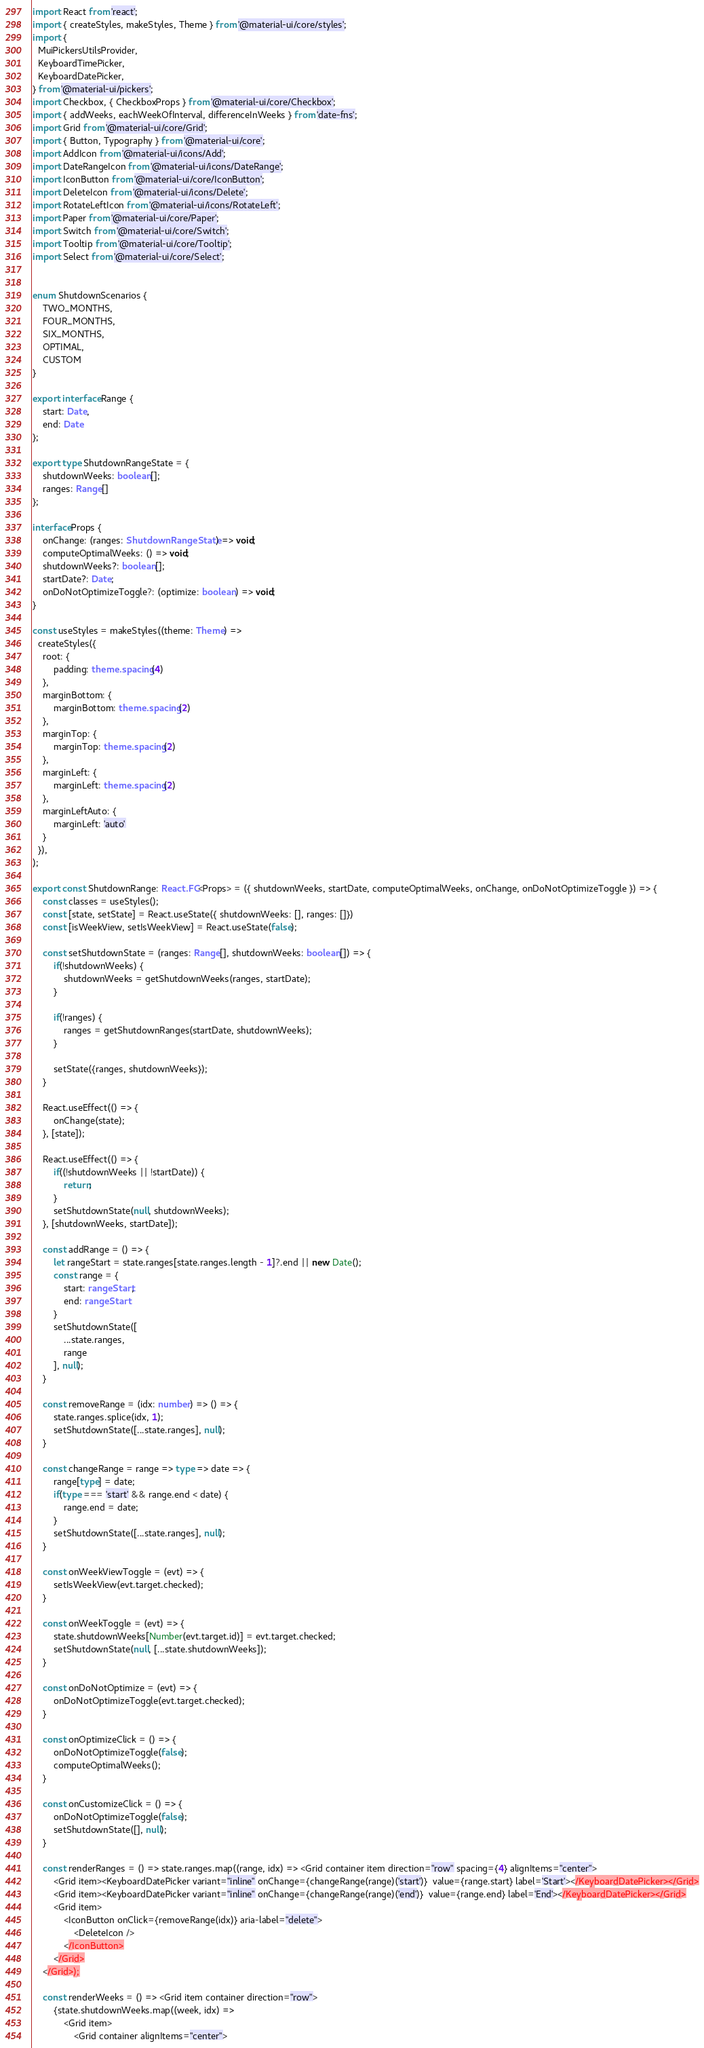<code> <loc_0><loc_0><loc_500><loc_500><_TypeScript_>import React from 'react';
import { createStyles, makeStyles, Theme } from '@material-ui/core/styles';
import {
  MuiPickersUtilsProvider,
  KeyboardTimePicker,
  KeyboardDatePicker,
} from '@material-ui/pickers';
import Checkbox, { CheckboxProps } from '@material-ui/core/Checkbox';
import { addWeeks, eachWeekOfInterval, differenceInWeeks } from 'date-fns';
import Grid from '@material-ui/core/Grid';
import { Button, Typography } from '@material-ui/core';
import AddIcon from '@material-ui/icons/Add';
import DateRangeIcon from '@material-ui/icons/DateRange';
import IconButton from '@material-ui/core/IconButton';
import DeleteIcon from '@material-ui/icons/Delete';
import RotateLeftIcon from '@material-ui/icons/RotateLeft';
import Paper from '@material-ui/core/Paper';
import Switch from '@material-ui/core/Switch';
import Tooltip from '@material-ui/core/Tooltip';
import Select from '@material-ui/core/Select';


enum ShutdownScenarios {
    TWO_MONTHS,
    FOUR_MONTHS,
    SIX_MONTHS,
    OPTIMAL,
    CUSTOM
}

export interface Range {
    start: Date,
    end: Date
};

export type ShutdownRangeState = {
    shutdownWeeks: boolean[];
    ranges: Range[]
};

interface Props {
    onChange: (ranges: ShutdownRangeState) => void;
    computeOptimalWeeks: () => void;
    shutdownWeeks?: boolean[];
    startDate?: Date;
    onDoNotOptimizeToggle?: (optimize: boolean) => void;
}

const useStyles = makeStyles((theme: Theme) =>
  createStyles({
    root: {
        padding: theme.spacing(4)
    },
    marginBottom: {
        marginBottom: theme.spacing(2)
    },
    marginTop: {
        marginTop: theme.spacing(2)
    },
    marginLeft: {
        marginLeft: theme.spacing(2)
    },
    marginLeftAuto: {
        marginLeft: 'auto'
    }
  }),
);

export const ShutdownRange: React.FC<Props> = ({ shutdownWeeks, startDate, computeOptimalWeeks, onChange, onDoNotOptimizeToggle }) => {
    const classes = useStyles();
    const [state, setState] = React.useState({ shutdownWeeks: [], ranges: []})
    const [isWeekView, setIsWeekView] = React.useState(false);

    const setShutdownState = (ranges: Range[], shutdownWeeks: boolean[]) => {
        if(!shutdownWeeks) {
            shutdownWeeks = getShutdownWeeks(ranges, startDate);
        }

        if(!ranges) {
            ranges = getShutdownRanges(startDate, shutdownWeeks);
        }

        setState({ranges, shutdownWeeks});
    }

    React.useEffect(() => {
        onChange(state);
    }, [state]);

    React.useEffect(() => {
        if((!shutdownWeeks || !startDate)) {
            return;
        }
        setShutdownState(null, shutdownWeeks);
    }, [shutdownWeeks, startDate]);

    const addRange = () => {
        let rangeStart = state.ranges[state.ranges.length - 1]?.end || new Date();
        const range = {
            start: rangeStart,
            end: rangeStart
        }
        setShutdownState([
            ...state.ranges,
            range
        ], null);
    }

    const removeRange = (idx: number) => () => {
        state.ranges.splice(idx, 1);
        setShutdownState([...state.ranges], null);
    }

    const changeRange = range => type => date => {
        range[type] = date;
        if(type === 'start' && range.end < date) {
            range.end = date;
        }
        setShutdownState([...state.ranges], null);
    }

    const onWeekViewToggle = (evt) => {
        setIsWeekView(evt.target.checked);
    }

    const onWeekToggle = (evt) => {
        state.shutdownWeeks[Number(evt.target.id)] = evt.target.checked;
        setShutdownState(null, [...state.shutdownWeeks]);
    }

    const onDoNotOptimize = (evt) => {
        onDoNotOptimizeToggle(evt.target.checked);
    }

    const onOptimizeClick = () => {
        onDoNotOptimizeToggle(false);
        computeOptimalWeeks();
    }

    const onCustomizeClick = () => {
        onDoNotOptimizeToggle(false);
        setShutdownState([], null);
    }

    const renderRanges = () => state.ranges.map((range, idx) => <Grid container item direction="row" spacing={4} alignItems="center">
        <Grid item><KeyboardDatePicker variant="inline" onChange={changeRange(range)('start')}  value={range.start} label='Start'></KeyboardDatePicker></Grid>
        <Grid item><KeyboardDatePicker variant="inline" onChange={changeRange(range)('end')}  value={range.end} label='End'></KeyboardDatePicker></Grid>
        <Grid item>
            <IconButton onClick={removeRange(idx)} aria-label="delete">
                <DeleteIcon />
            </IconButton>
        </Grid>
    </Grid>);

    const renderWeeks = () => <Grid item container direction="row">
        {state.shutdownWeeks.map((week, idx) => 
            <Grid item>
                <Grid container alignItems="center"></code> 